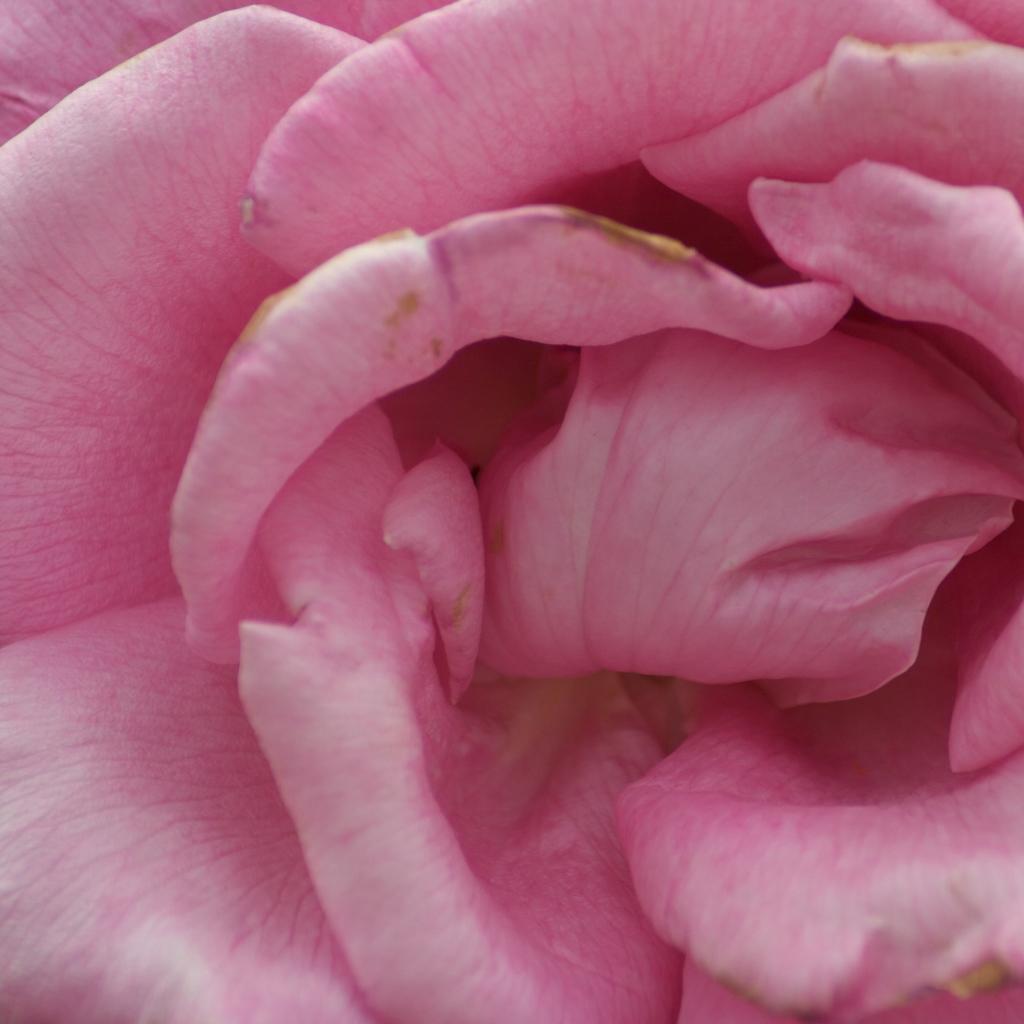Describe this image in one or two sentences. In this image I can see a pink color rose. This image is taken may be during a day. 